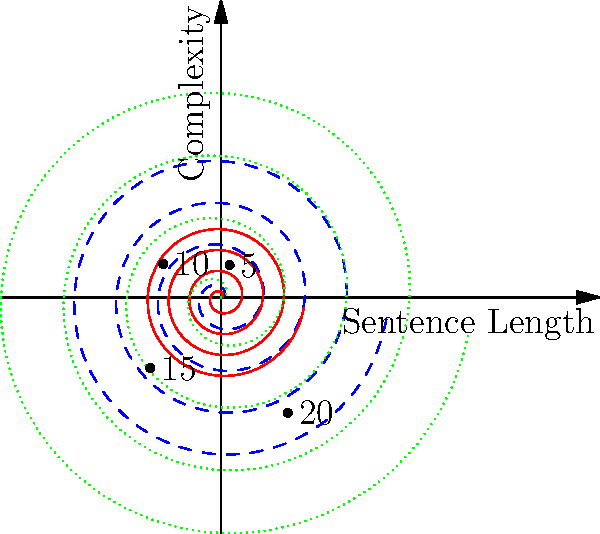In the spiral plot representing sentence complexity across languages, which language shows the highest rate of increase in complexity as sentence length grows? To determine which language shows the highest rate of increase in complexity as sentence length grows, we need to analyze the spiral plot:

1. The plot uses polar coordinates to represent sentence length (angle) and complexity (radius).
2. Three languages are represented: Spanish (blue dashed line), Portuguese (red solid line), and English (green dotted line).
3. The rate of increase in complexity is represented by how quickly the spiral expands outward.

Analyzing each language:
1. Spanish (blue dashed line): Shows a moderate rate of increase.
2. Portuguese (red solid line): Has the slowest rate of increase, as the spiral expands the least.
3. English (green dotted line): Demonstrates the fastest rate of increase, with the spiral expanding outward more rapidly than the other two languages.

The steeper the slope of the spiral, the faster the complexity increases with sentence length. The English spiral has the steepest slope, indicating that it has the highest rate of increase in complexity as sentence length grows.
Answer: English 